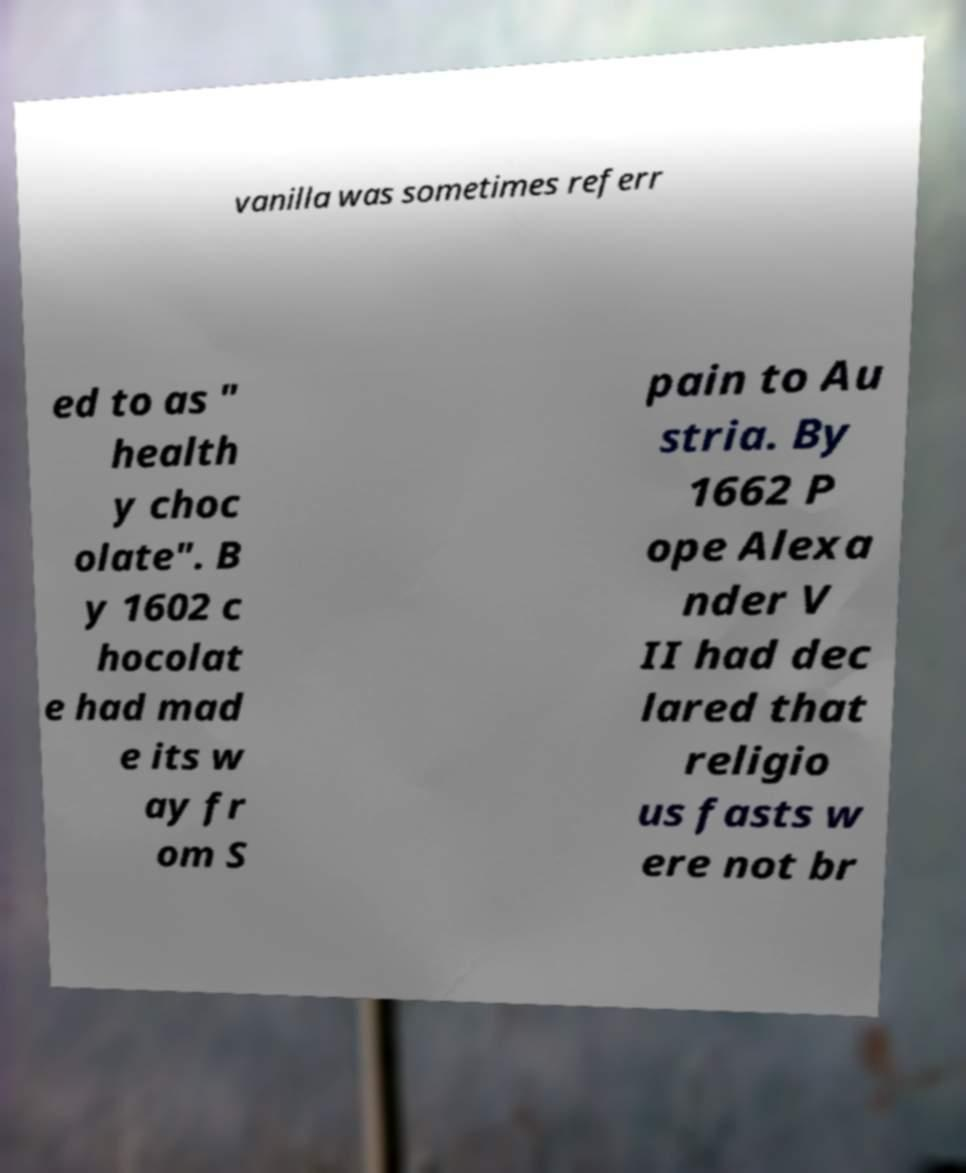What messages or text are displayed in this image? I need them in a readable, typed format. vanilla was sometimes referr ed to as " health y choc olate". B y 1602 c hocolat e had mad e its w ay fr om S pain to Au stria. By 1662 P ope Alexa nder V II had dec lared that religio us fasts w ere not br 